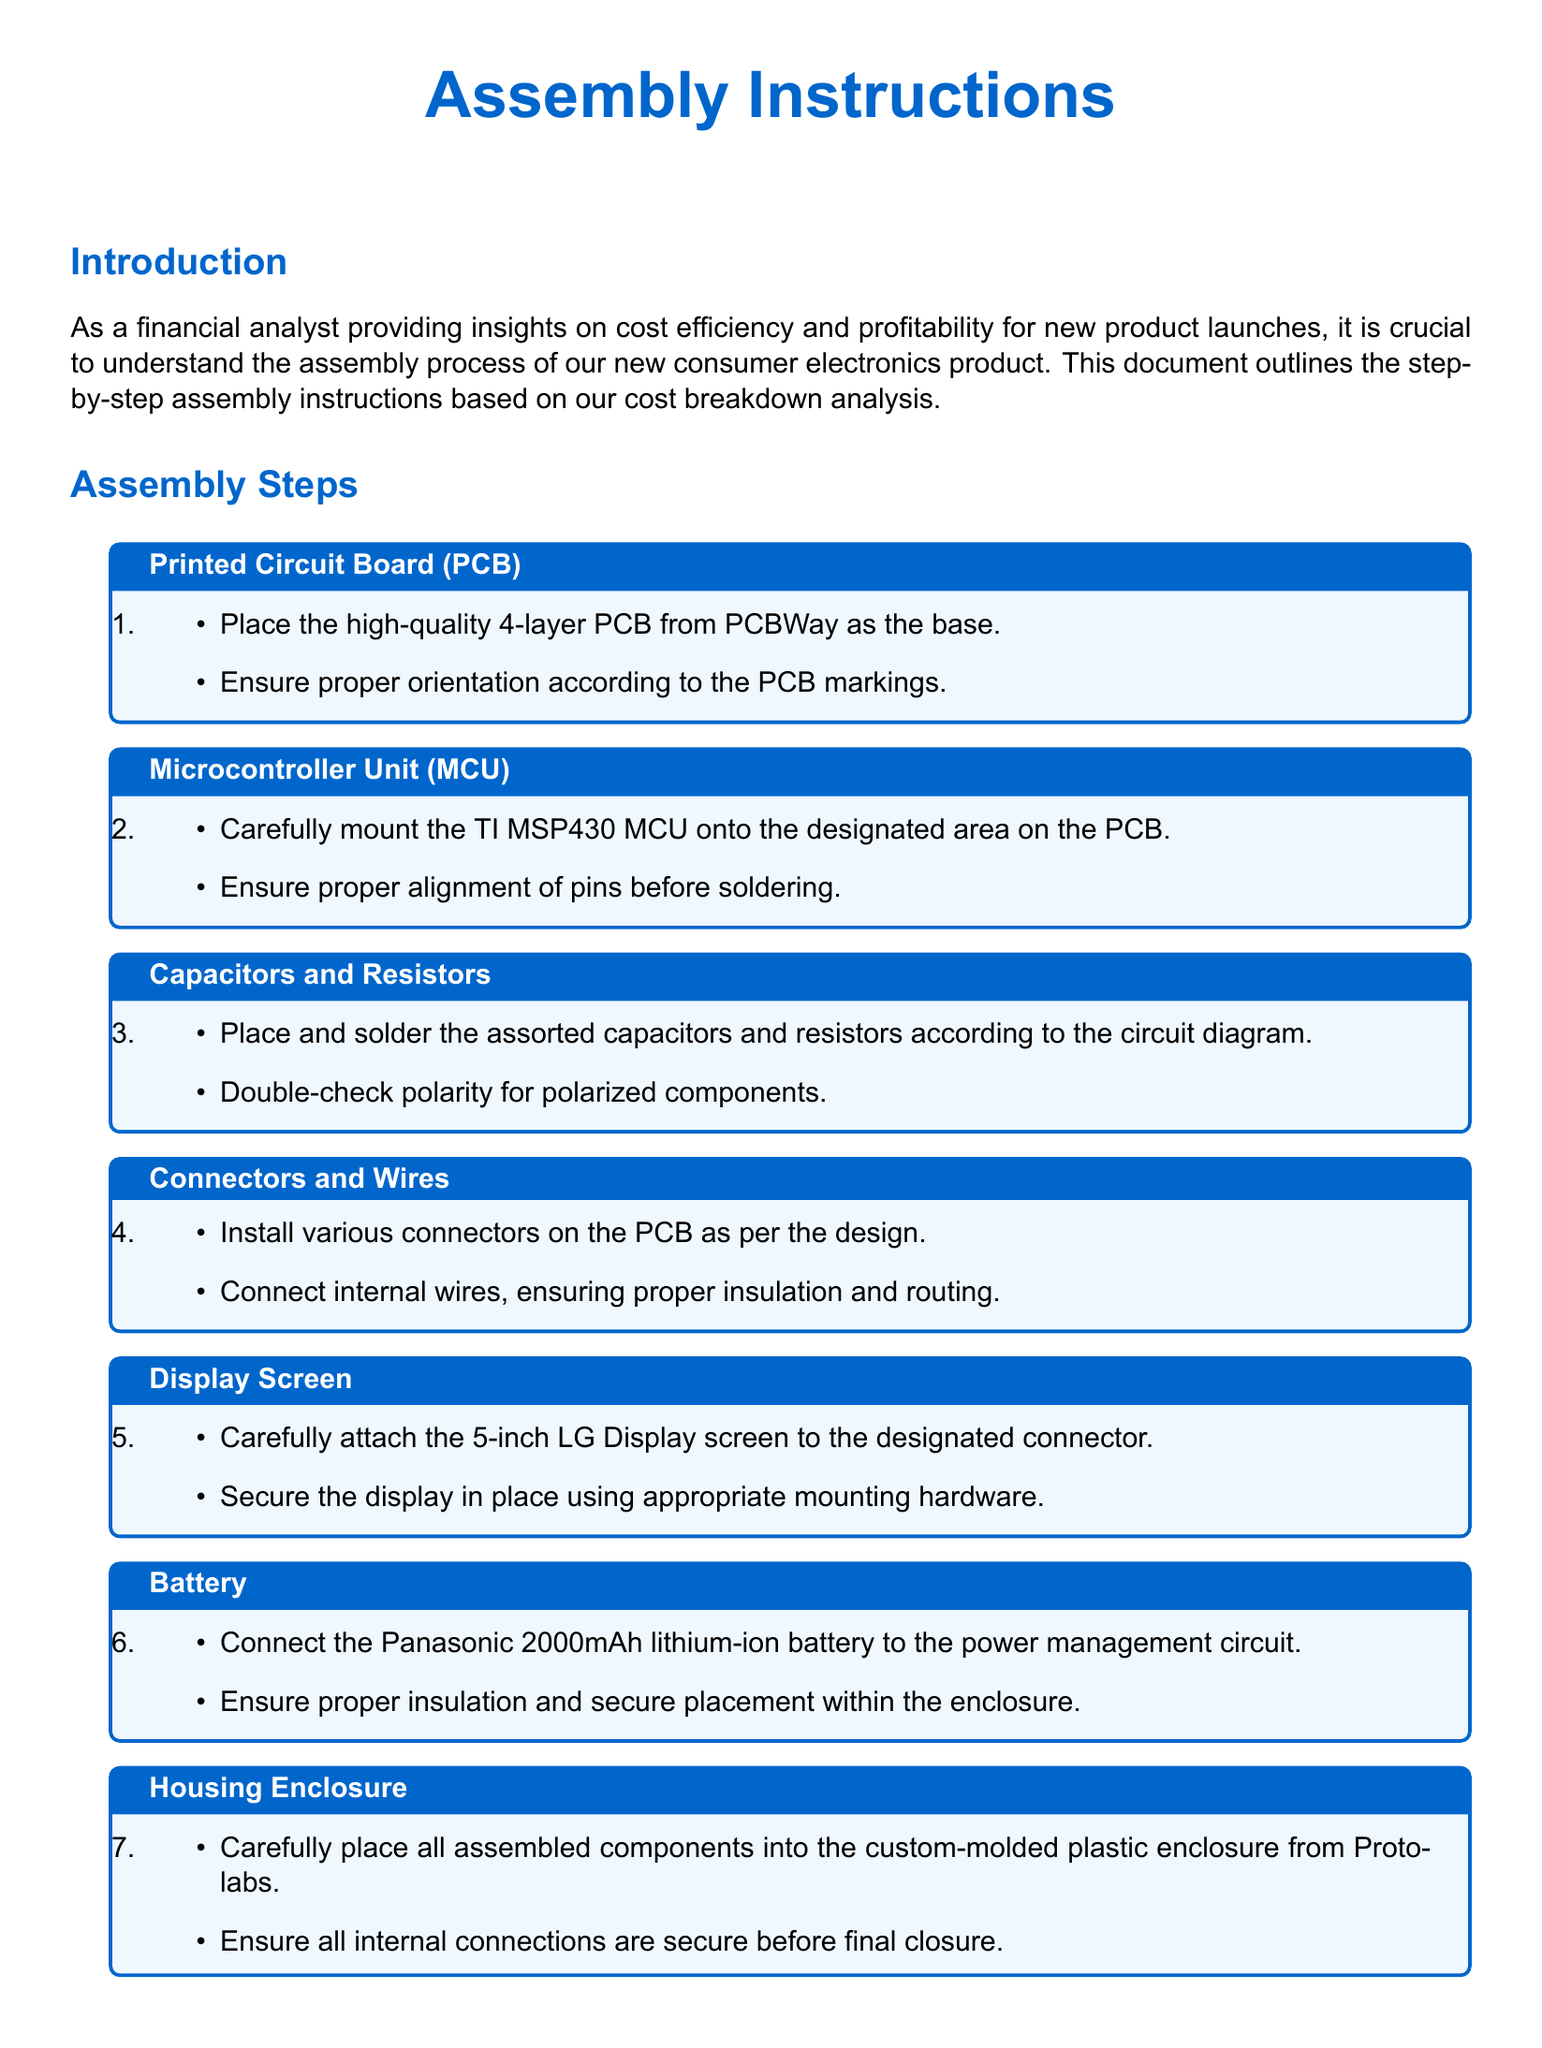what is the total component cost for 5,000 units? The total component cost is explicitly mentioned in the cost efficiency note section of the document.
Answer: $161,750 how much are the additional costs? This information is found in the cost efficiency note, specifying all additional costs associated with assembly.
Answer: $40,000 what is the cost per unit? The cost per unit is calculated and stated in the cost efficiency note section of the document.
Answer: $40.35 who manufactures the microcontroller unit? The document mentions the name of the manufacturer for the microcontroller unit within the assembly steps.
Answer: TI what type of display screen is used? The assembly instructions specify the display screen model within the relevant step.
Answer: LG how many layers does the PCB have? The assembly instructions highlight the characteristics of the PCB, specifically its number of layers.
Answer: 4-layer what is the battery capacity mentioned? The assembly instructions provide the capacity of the battery used in the assembly.
Answer: 2000mAh which company supplies the housing enclosure? The document indicates the supplier of the housing enclosure in the assembly steps.
Answer: Protolabs what is the purpose of quality control? The document outlines the significance of quality control in relation to product performance and cost efficiency.
Answer: Ensure functionality how is the capacitor and resistor placement described? The assembly instructions outline the process for placing and soldering capacitors and resistors according to the circuit diagram.
Answer: According to the circuit diagram 